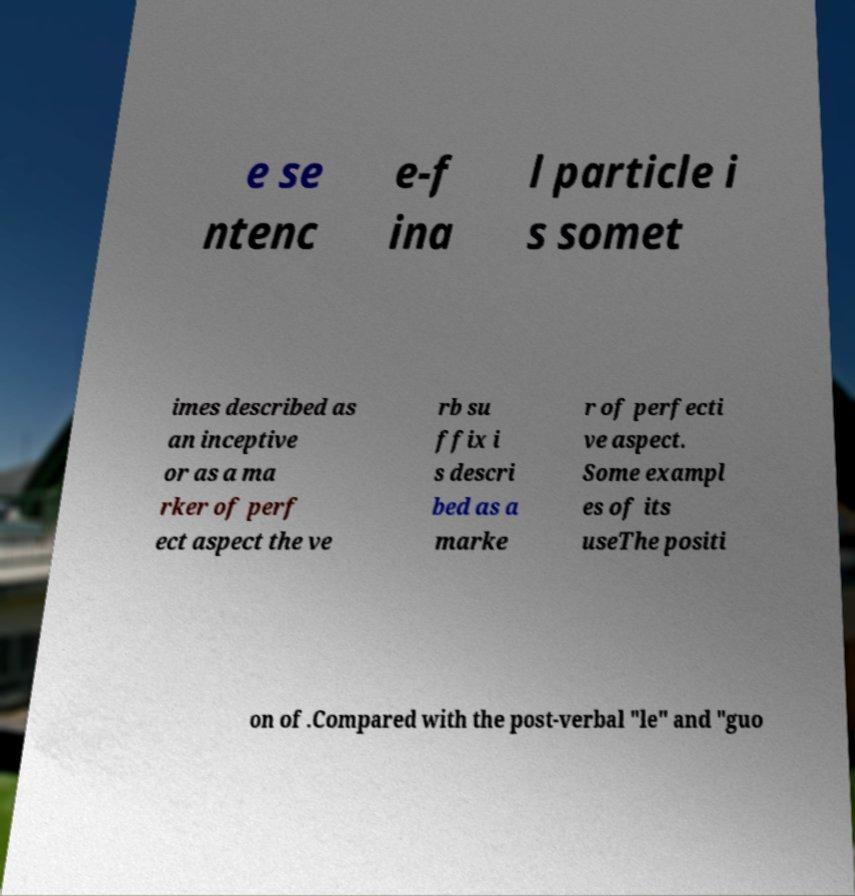There's text embedded in this image that I need extracted. Can you transcribe it verbatim? e se ntenc e-f ina l particle i s somet imes described as an inceptive or as a ma rker of perf ect aspect the ve rb su ffix i s descri bed as a marke r of perfecti ve aspect. Some exampl es of its useThe positi on of .Compared with the post-verbal "le" and "guo 